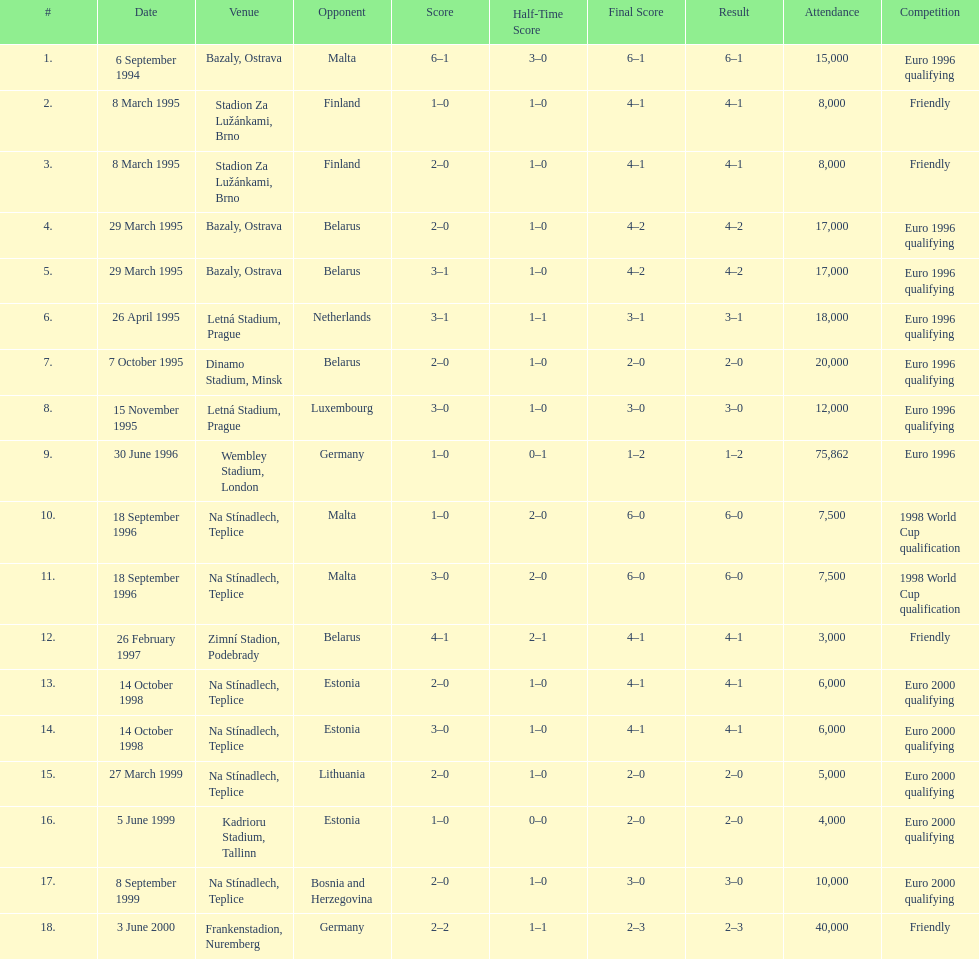How many games took place in ostrava? 2. 